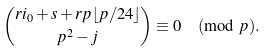Convert formula to latex. <formula><loc_0><loc_0><loc_500><loc_500>\binom { r i _ { 0 } + s + r p \lfloor p / 2 4 \rfloor } { p ^ { 2 } - j } \equiv 0 \pmod { p } .</formula> 